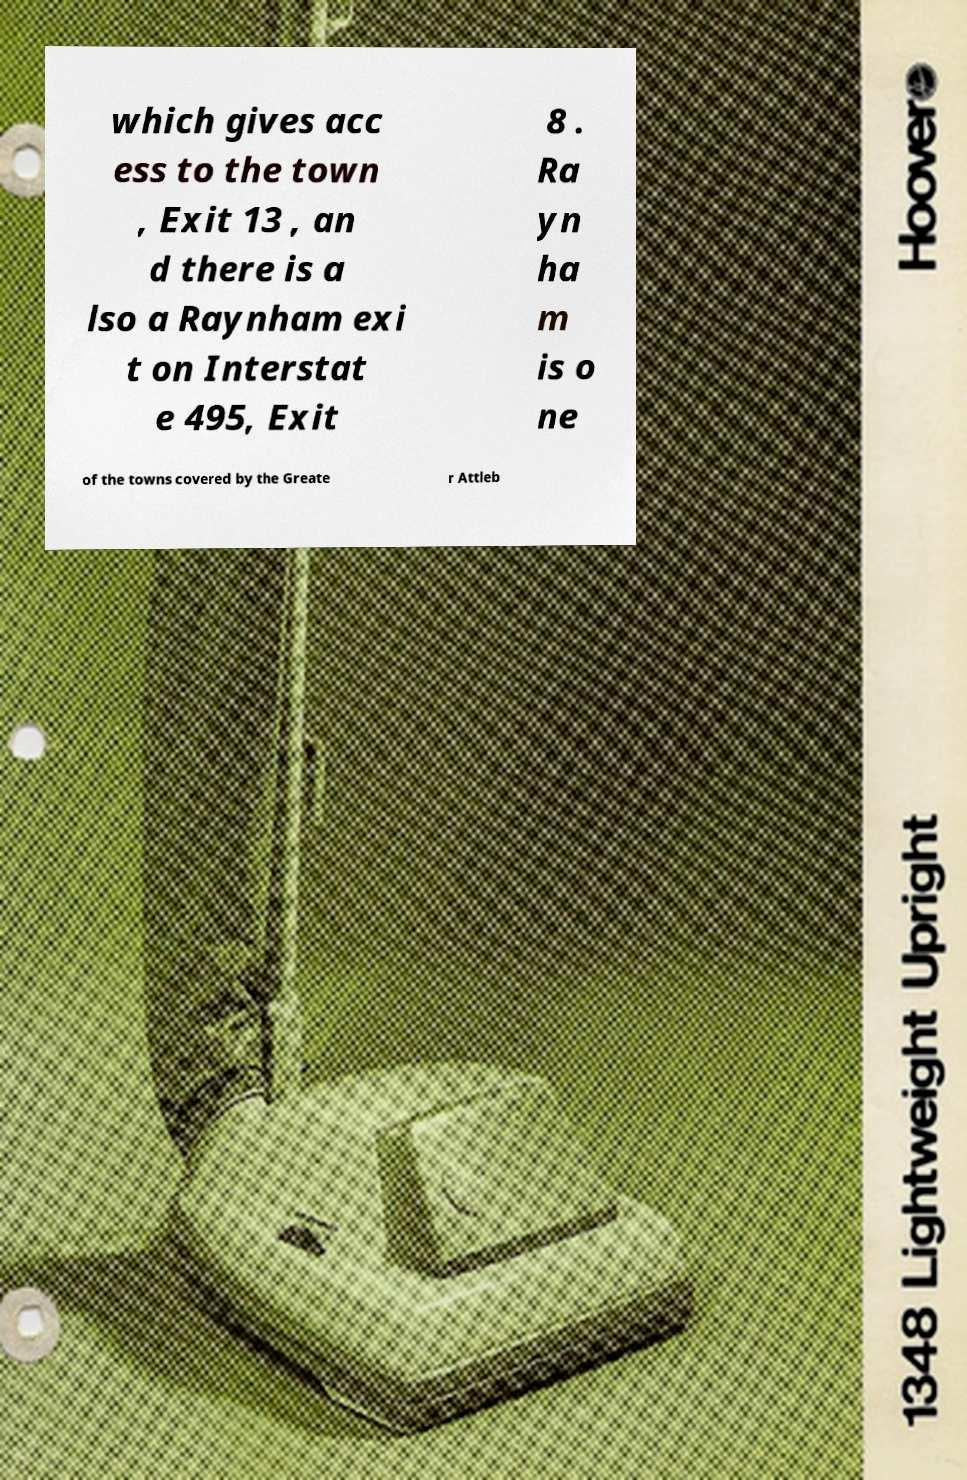Please read and relay the text visible in this image. What does it say? which gives acc ess to the town , Exit 13 , an d there is a lso a Raynham exi t on Interstat e 495, Exit 8 . Ra yn ha m is o ne of the towns covered by the Greate r Attleb 